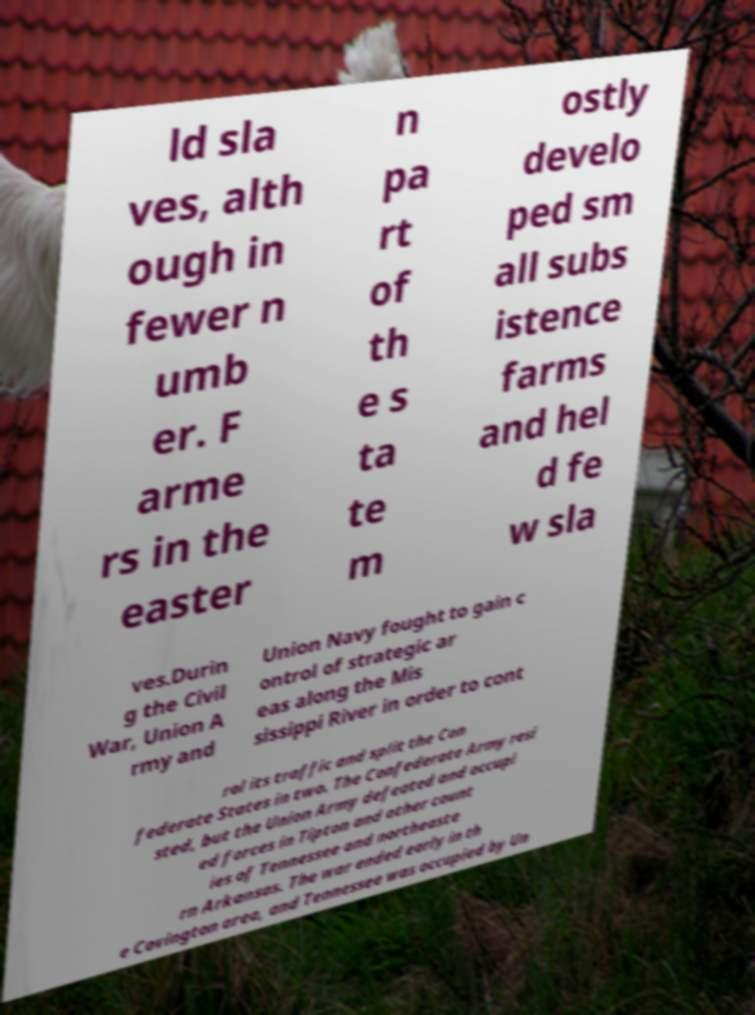Can you read and provide the text displayed in the image?This photo seems to have some interesting text. Can you extract and type it out for me? ld sla ves, alth ough in fewer n umb er. F arme rs in the easter n pa rt of th e s ta te m ostly develo ped sm all subs istence farms and hel d fe w sla ves.Durin g the Civil War, Union A rmy and Union Navy fought to gain c ontrol of strategic ar eas along the Mis sissippi River in order to cont rol its traffic and split the Con federate States in two. The Confederate Army resi sted, but the Union Army defeated and occupi ed forces in Tipton and other count ies of Tennessee and northeaste rn Arkansas. The war ended early in th e Covington area, and Tennessee was occupied by Un 